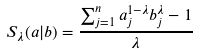<formula> <loc_0><loc_0><loc_500><loc_500>S _ { \lambda } ( a | b ) = \frac { \sum _ { j = 1 } ^ { n } a _ { j } ^ { 1 - \lambda } b _ { j } ^ { \lambda } - 1 } { \lambda }</formula> 